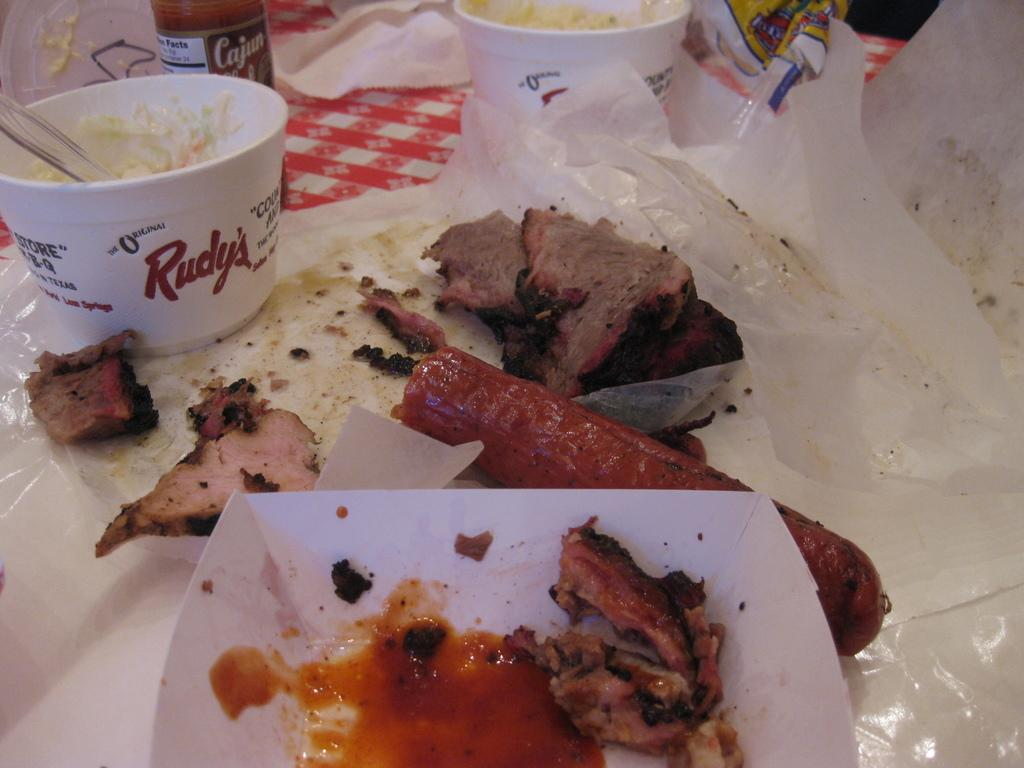What type of objects can be seen in the image? There are food items, bowls, a container, covers, and a bottle in the image. What might be used to hold or serve the food items? The bowls and container in the image might be used to hold or serve the food items. What could be used to cover the food items? The covers in the image could be used to cover the food items. Is there a river flowing through the food items in the image? No, there is no river present in the image. Is there a knife visible in the image? No, there is no knife present in the image. 